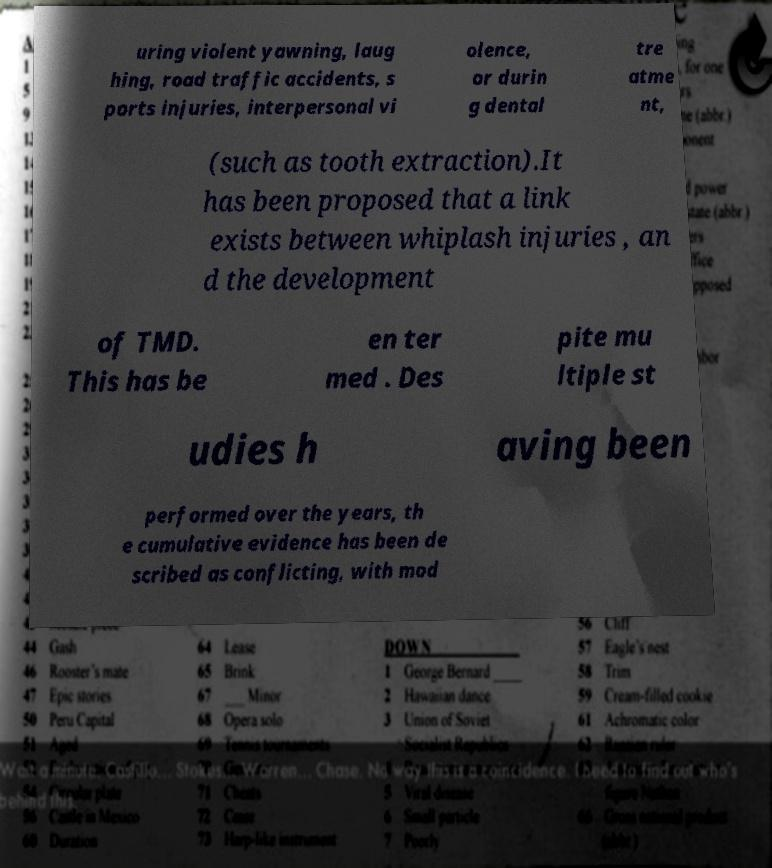Could you extract and type out the text from this image? uring violent yawning, laug hing, road traffic accidents, s ports injuries, interpersonal vi olence, or durin g dental tre atme nt, (such as tooth extraction).It has been proposed that a link exists between whiplash injuries , an d the development of TMD. This has be en ter med . Des pite mu ltiple st udies h aving been performed over the years, th e cumulative evidence has been de scribed as conflicting, with mod 